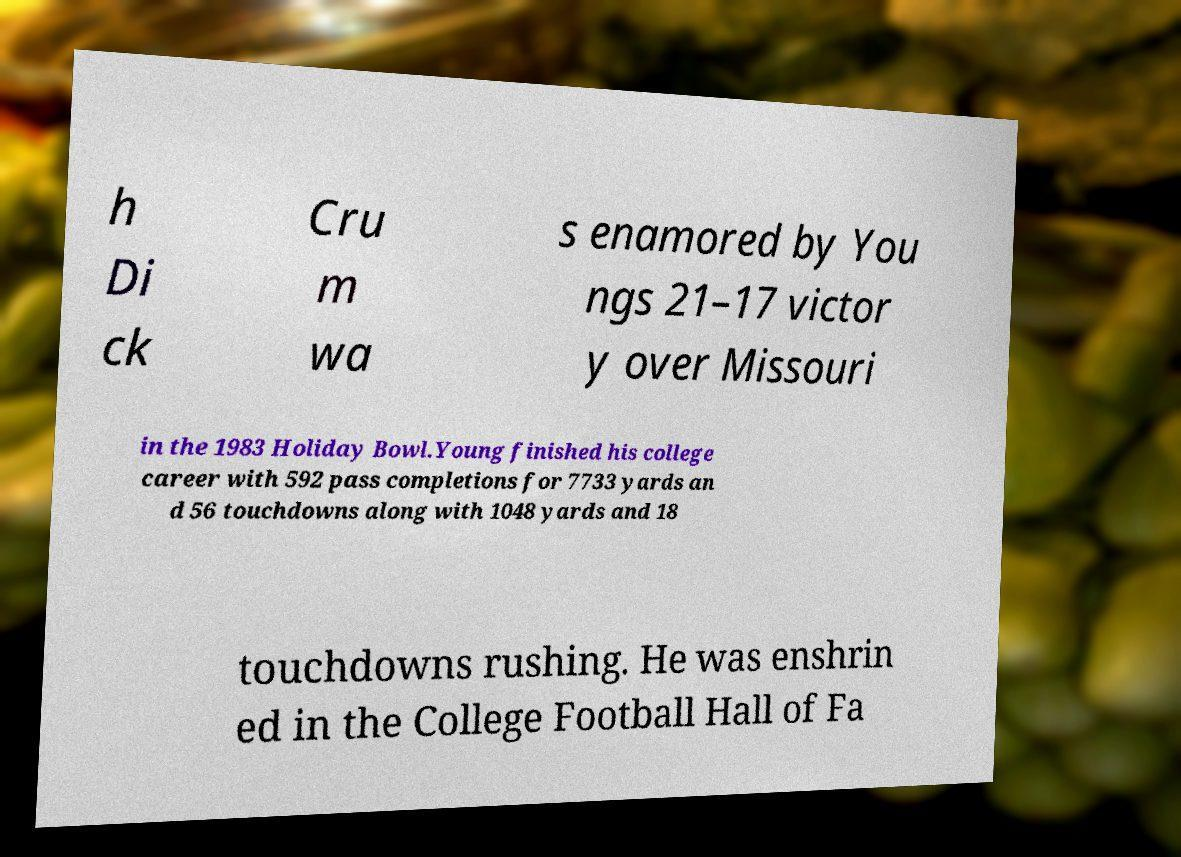There's text embedded in this image that I need extracted. Can you transcribe it verbatim? h Di ck Cru m wa s enamored by You ngs 21–17 victor y over Missouri in the 1983 Holiday Bowl.Young finished his college career with 592 pass completions for 7733 yards an d 56 touchdowns along with 1048 yards and 18 touchdowns rushing. He was enshrin ed in the College Football Hall of Fa 